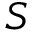Convert formula to latex. <formula><loc_0><loc_0><loc_500><loc_500>S</formula> 